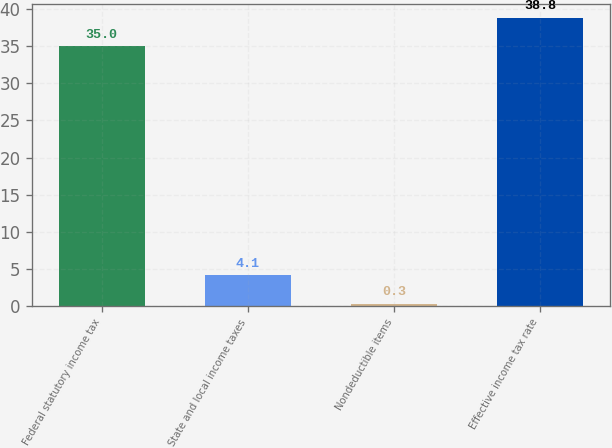Convert chart. <chart><loc_0><loc_0><loc_500><loc_500><bar_chart><fcel>Federal statutory income tax<fcel>State and local income taxes<fcel>Nondeductible items<fcel>Effective income tax rate<nl><fcel>35<fcel>4.1<fcel>0.3<fcel>38.8<nl></chart> 